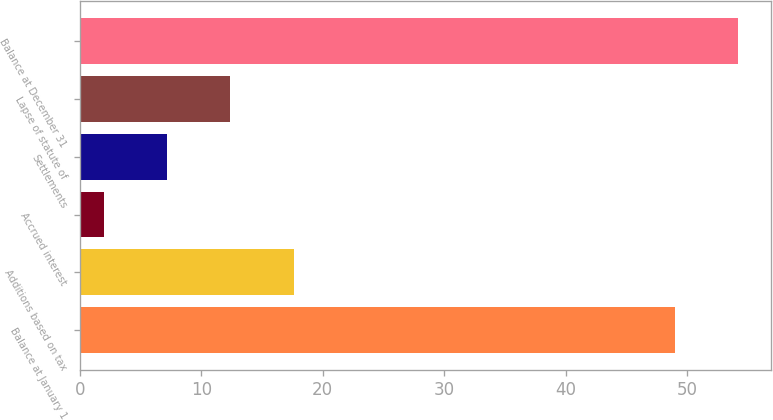Convert chart to OTSL. <chart><loc_0><loc_0><loc_500><loc_500><bar_chart><fcel>Balance at January 1<fcel>Additions based on tax<fcel>Accrued interest<fcel>Settlements<fcel>Lapse of statute of<fcel>Balance at December 31<nl><fcel>49<fcel>17.6<fcel>2<fcel>7.2<fcel>12.4<fcel>54.2<nl></chart> 